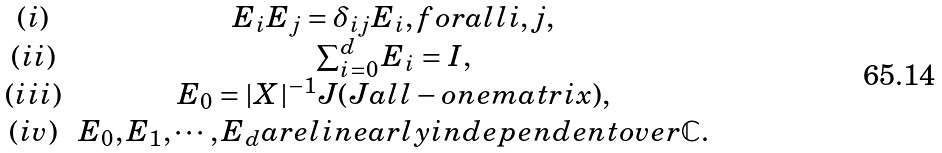Convert formula to latex. <formula><loc_0><loc_0><loc_500><loc_500>\begin{array} { c c } ( i ) & { E _ { i } E _ { j } = \delta _ { i j } E _ { i } , f o r a l l i , j , } \\ ( i i ) & { \sum _ { i = 0 } ^ { d } E _ { i } = I , } \\ ( i i i ) & { E _ { 0 } = | X | ^ { - 1 } J ( J a l l - o n e m a t r i x ) , } \\ ( i v ) & { E _ { 0 } , E _ { 1 } , \cdots , E _ { d } a r e l i n e a r l y i n d e p e n d e n t o v e r \mathbb { C } . } \end{array}</formula> 